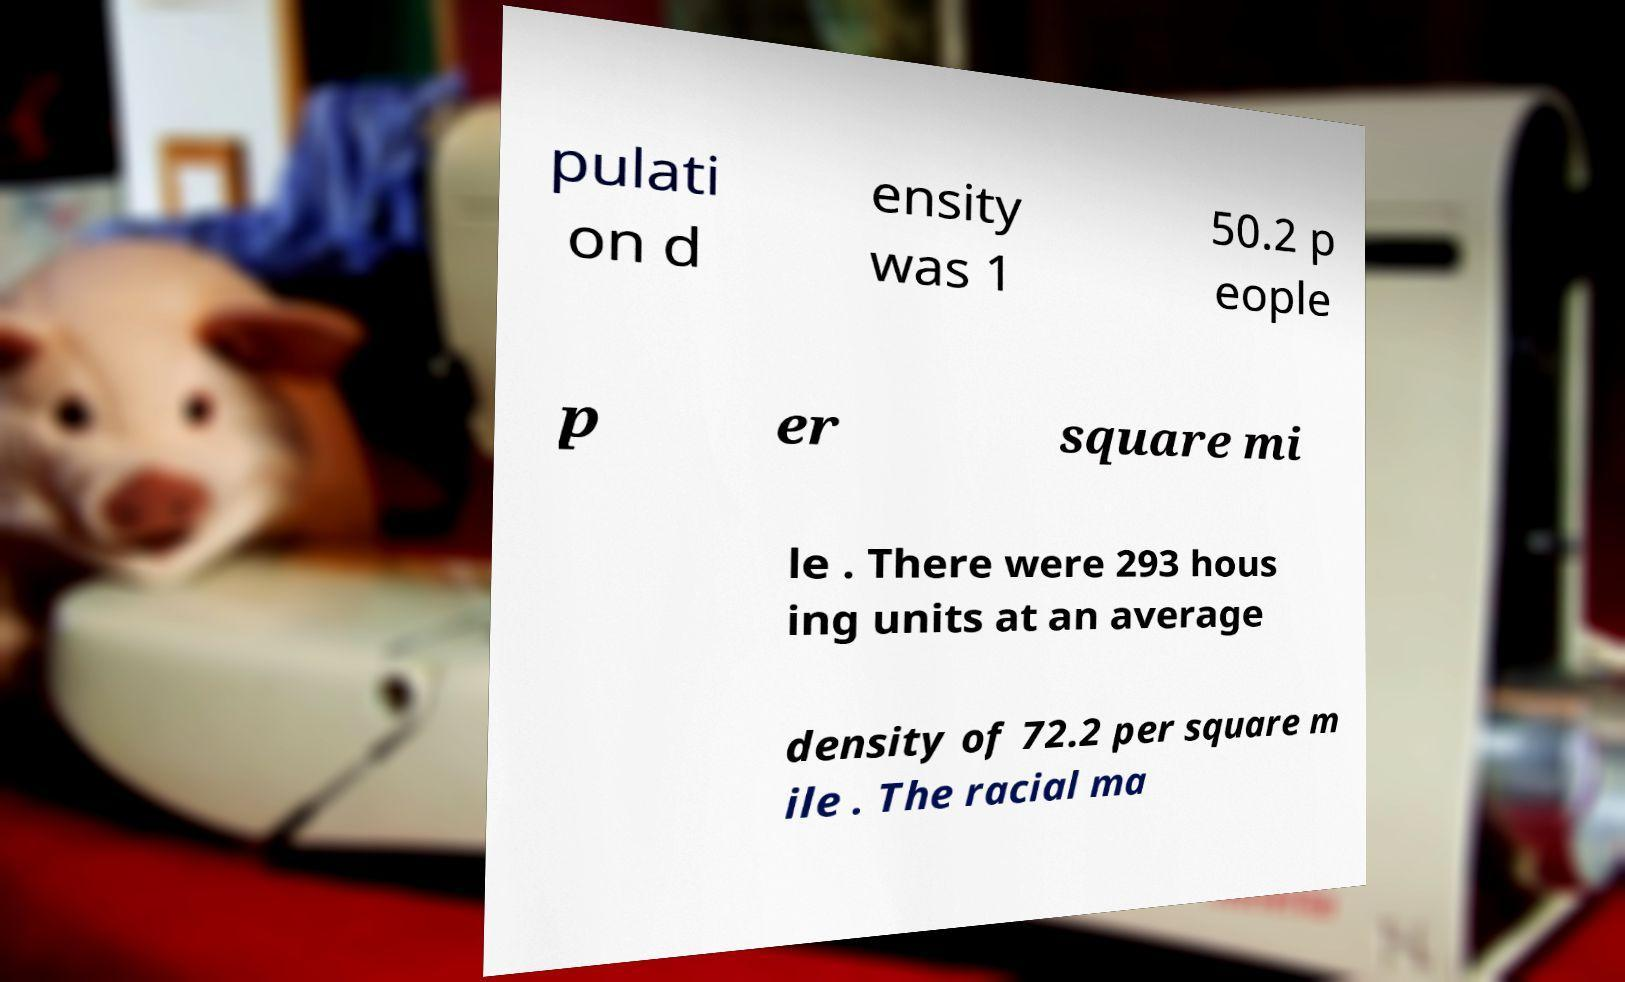Can you read and provide the text displayed in the image?This photo seems to have some interesting text. Can you extract and type it out for me? pulati on d ensity was 1 50.2 p eople p er square mi le . There were 293 hous ing units at an average density of 72.2 per square m ile . The racial ma 